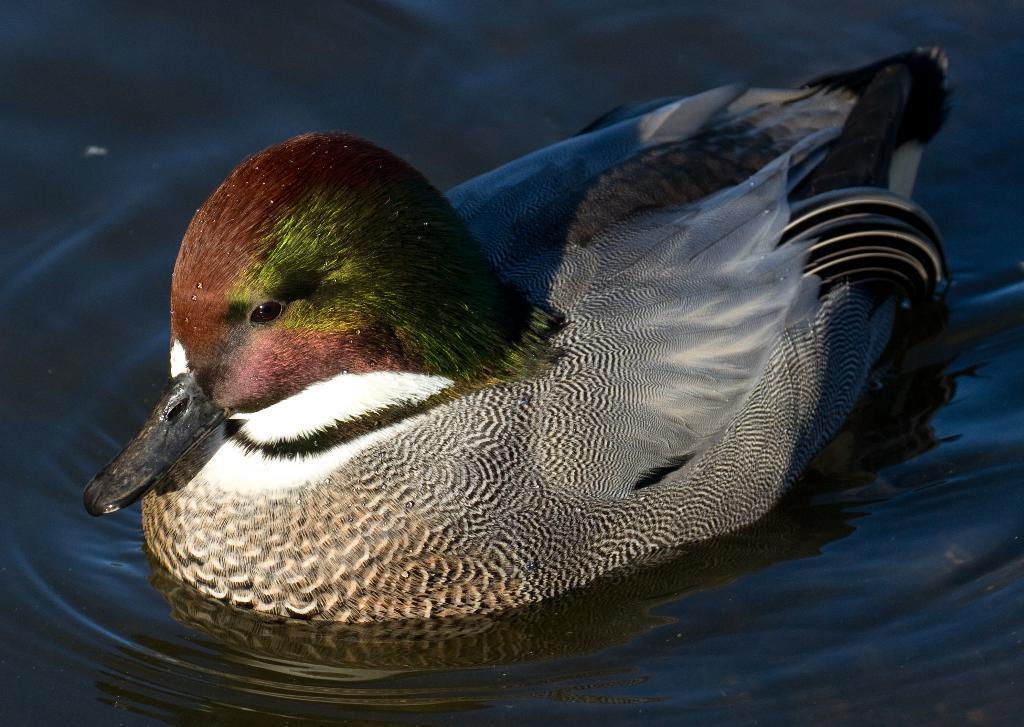Please provide a concise description of this image. In this picture I can see a duck in the water. 